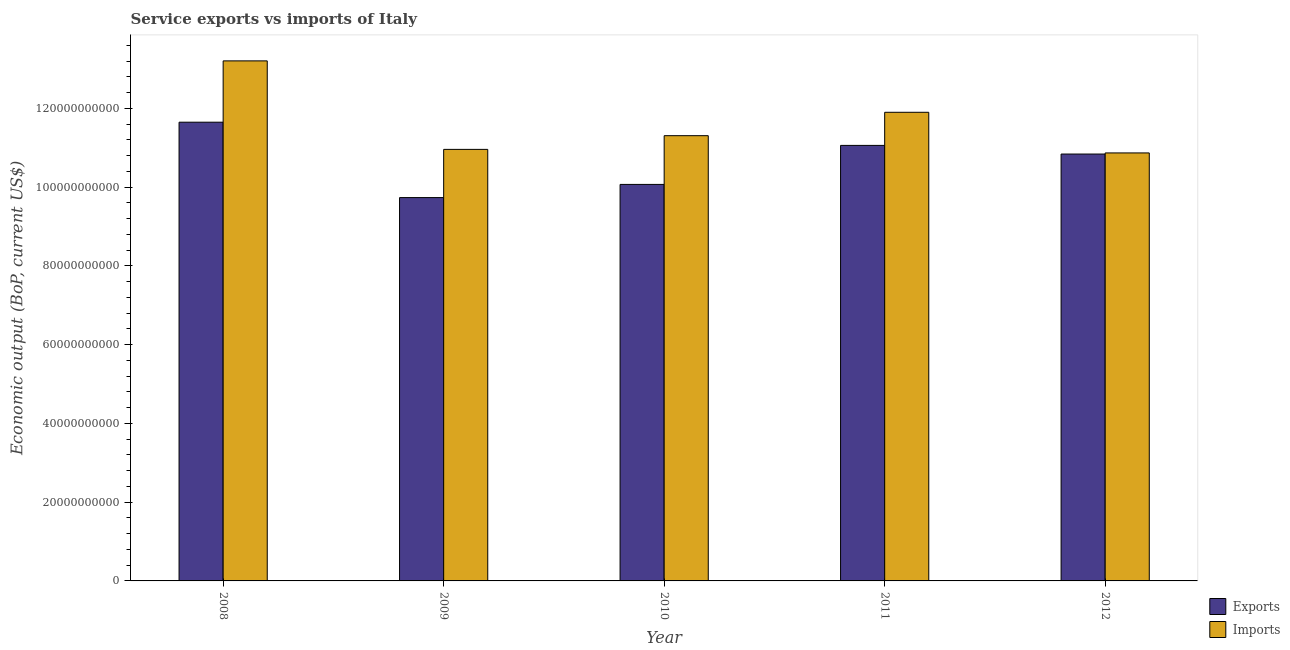Are the number of bars per tick equal to the number of legend labels?
Provide a succinct answer. Yes. How many bars are there on the 4th tick from the left?
Keep it short and to the point. 2. How many bars are there on the 3rd tick from the right?
Your answer should be very brief. 2. What is the label of the 1st group of bars from the left?
Offer a very short reply. 2008. In how many cases, is the number of bars for a given year not equal to the number of legend labels?
Offer a terse response. 0. What is the amount of service exports in 2011?
Make the answer very short. 1.11e+11. Across all years, what is the maximum amount of service exports?
Your answer should be very brief. 1.16e+11. Across all years, what is the minimum amount of service exports?
Your answer should be very brief. 9.73e+1. In which year was the amount of service imports minimum?
Provide a short and direct response. 2012. What is the total amount of service imports in the graph?
Offer a very short reply. 5.82e+11. What is the difference between the amount of service exports in 2009 and that in 2012?
Give a very brief answer. -1.11e+1. What is the difference between the amount of service exports in 2012 and the amount of service imports in 2009?
Provide a short and direct response. 1.11e+1. What is the average amount of service exports per year?
Your response must be concise. 1.07e+11. In the year 2010, what is the difference between the amount of service imports and amount of service exports?
Your answer should be very brief. 0. What is the ratio of the amount of service exports in 2011 to that in 2012?
Provide a succinct answer. 1.02. Is the amount of service imports in 2009 less than that in 2012?
Your answer should be very brief. No. Is the difference between the amount of service exports in 2011 and 2012 greater than the difference between the amount of service imports in 2011 and 2012?
Offer a terse response. No. What is the difference between the highest and the second highest amount of service exports?
Ensure brevity in your answer.  5.89e+09. What is the difference between the highest and the lowest amount of service imports?
Provide a short and direct response. 2.34e+1. In how many years, is the amount of service imports greater than the average amount of service imports taken over all years?
Provide a succinct answer. 2. Is the sum of the amount of service exports in 2010 and 2012 greater than the maximum amount of service imports across all years?
Offer a very short reply. Yes. What does the 2nd bar from the left in 2012 represents?
Keep it short and to the point. Imports. What does the 2nd bar from the right in 2009 represents?
Provide a succinct answer. Exports. Does the graph contain any zero values?
Offer a very short reply. No. Where does the legend appear in the graph?
Offer a terse response. Bottom right. How many legend labels are there?
Provide a succinct answer. 2. What is the title of the graph?
Your answer should be compact. Service exports vs imports of Italy. What is the label or title of the X-axis?
Offer a terse response. Year. What is the label or title of the Y-axis?
Keep it short and to the point. Economic output (BoP, current US$). What is the Economic output (BoP, current US$) of Exports in 2008?
Give a very brief answer. 1.16e+11. What is the Economic output (BoP, current US$) in Imports in 2008?
Your answer should be compact. 1.32e+11. What is the Economic output (BoP, current US$) in Exports in 2009?
Your answer should be very brief. 9.73e+1. What is the Economic output (BoP, current US$) of Imports in 2009?
Your response must be concise. 1.10e+11. What is the Economic output (BoP, current US$) in Exports in 2010?
Your response must be concise. 1.01e+11. What is the Economic output (BoP, current US$) of Imports in 2010?
Provide a short and direct response. 1.13e+11. What is the Economic output (BoP, current US$) in Exports in 2011?
Make the answer very short. 1.11e+11. What is the Economic output (BoP, current US$) in Imports in 2011?
Your answer should be very brief. 1.19e+11. What is the Economic output (BoP, current US$) in Exports in 2012?
Make the answer very short. 1.08e+11. What is the Economic output (BoP, current US$) in Imports in 2012?
Keep it short and to the point. 1.09e+11. Across all years, what is the maximum Economic output (BoP, current US$) in Exports?
Give a very brief answer. 1.16e+11. Across all years, what is the maximum Economic output (BoP, current US$) of Imports?
Offer a terse response. 1.32e+11. Across all years, what is the minimum Economic output (BoP, current US$) in Exports?
Keep it short and to the point. 9.73e+1. Across all years, what is the minimum Economic output (BoP, current US$) of Imports?
Offer a very short reply. 1.09e+11. What is the total Economic output (BoP, current US$) in Exports in the graph?
Ensure brevity in your answer.  5.33e+11. What is the total Economic output (BoP, current US$) in Imports in the graph?
Ensure brevity in your answer.  5.82e+11. What is the difference between the Economic output (BoP, current US$) in Exports in 2008 and that in 2009?
Ensure brevity in your answer.  1.91e+1. What is the difference between the Economic output (BoP, current US$) of Imports in 2008 and that in 2009?
Give a very brief answer. 2.25e+1. What is the difference between the Economic output (BoP, current US$) in Exports in 2008 and that in 2010?
Make the answer very short. 1.58e+1. What is the difference between the Economic output (BoP, current US$) of Imports in 2008 and that in 2010?
Offer a very short reply. 1.90e+1. What is the difference between the Economic output (BoP, current US$) in Exports in 2008 and that in 2011?
Offer a terse response. 5.89e+09. What is the difference between the Economic output (BoP, current US$) of Imports in 2008 and that in 2011?
Provide a short and direct response. 1.31e+1. What is the difference between the Economic output (BoP, current US$) in Exports in 2008 and that in 2012?
Make the answer very short. 8.09e+09. What is the difference between the Economic output (BoP, current US$) in Imports in 2008 and that in 2012?
Keep it short and to the point. 2.34e+1. What is the difference between the Economic output (BoP, current US$) of Exports in 2009 and that in 2010?
Provide a short and direct response. -3.34e+09. What is the difference between the Economic output (BoP, current US$) in Imports in 2009 and that in 2010?
Make the answer very short. -3.48e+09. What is the difference between the Economic output (BoP, current US$) in Exports in 2009 and that in 2011?
Provide a succinct answer. -1.33e+1. What is the difference between the Economic output (BoP, current US$) of Imports in 2009 and that in 2011?
Provide a short and direct response. -9.42e+09. What is the difference between the Economic output (BoP, current US$) in Exports in 2009 and that in 2012?
Make the answer very short. -1.11e+1. What is the difference between the Economic output (BoP, current US$) of Imports in 2009 and that in 2012?
Offer a very short reply. 9.00e+08. What is the difference between the Economic output (BoP, current US$) of Exports in 2010 and that in 2011?
Give a very brief answer. -9.91e+09. What is the difference between the Economic output (BoP, current US$) of Imports in 2010 and that in 2011?
Provide a short and direct response. -5.94e+09. What is the difference between the Economic output (BoP, current US$) of Exports in 2010 and that in 2012?
Provide a short and direct response. -7.71e+09. What is the difference between the Economic output (BoP, current US$) in Imports in 2010 and that in 2012?
Give a very brief answer. 4.38e+09. What is the difference between the Economic output (BoP, current US$) of Exports in 2011 and that in 2012?
Offer a terse response. 2.20e+09. What is the difference between the Economic output (BoP, current US$) in Imports in 2011 and that in 2012?
Provide a short and direct response. 1.03e+1. What is the difference between the Economic output (BoP, current US$) of Exports in 2008 and the Economic output (BoP, current US$) of Imports in 2009?
Provide a short and direct response. 6.90e+09. What is the difference between the Economic output (BoP, current US$) of Exports in 2008 and the Economic output (BoP, current US$) of Imports in 2010?
Offer a terse response. 3.42e+09. What is the difference between the Economic output (BoP, current US$) in Exports in 2008 and the Economic output (BoP, current US$) in Imports in 2011?
Offer a terse response. -2.52e+09. What is the difference between the Economic output (BoP, current US$) of Exports in 2008 and the Economic output (BoP, current US$) of Imports in 2012?
Make the answer very short. 7.80e+09. What is the difference between the Economic output (BoP, current US$) in Exports in 2009 and the Economic output (BoP, current US$) in Imports in 2010?
Your response must be concise. -1.57e+1. What is the difference between the Economic output (BoP, current US$) in Exports in 2009 and the Economic output (BoP, current US$) in Imports in 2011?
Give a very brief answer. -2.17e+1. What is the difference between the Economic output (BoP, current US$) of Exports in 2009 and the Economic output (BoP, current US$) of Imports in 2012?
Provide a short and direct response. -1.13e+1. What is the difference between the Economic output (BoP, current US$) in Exports in 2010 and the Economic output (BoP, current US$) in Imports in 2011?
Ensure brevity in your answer.  -1.83e+1. What is the difference between the Economic output (BoP, current US$) of Exports in 2010 and the Economic output (BoP, current US$) of Imports in 2012?
Give a very brief answer. -8.00e+09. What is the difference between the Economic output (BoP, current US$) of Exports in 2011 and the Economic output (BoP, current US$) of Imports in 2012?
Your response must be concise. 1.91e+09. What is the average Economic output (BoP, current US$) of Exports per year?
Provide a succinct answer. 1.07e+11. What is the average Economic output (BoP, current US$) in Imports per year?
Ensure brevity in your answer.  1.16e+11. In the year 2008, what is the difference between the Economic output (BoP, current US$) in Exports and Economic output (BoP, current US$) in Imports?
Ensure brevity in your answer.  -1.56e+1. In the year 2009, what is the difference between the Economic output (BoP, current US$) of Exports and Economic output (BoP, current US$) of Imports?
Keep it short and to the point. -1.22e+1. In the year 2010, what is the difference between the Economic output (BoP, current US$) in Exports and Economic output (BoP, current US$) in Imports?
Provide a succinct answer. -1.24e+1. In the year 2011, what is the difference between the Economic output (BoP, current US$) of Exports and Economic output (BoP, current US$) of Imports?
Provide a succinct answer. -8.41e+09. In the year 2012, what is the difference between the Economic output (BoP, current US$) in Exports and Economic output (BoP, current US$) in Imports?
Your answer should be very brief. -2.83e+08. What is the ratio of the Economic output (BoP, current US$) of Exports in 2008 to that in 2009?
Provide a succinct answer. 1.2. What is the ratio of the Economic output (BoP, current US$) of Imports in 2008 to that in 2009?
Provide a succinct answer. 1.21. What is the ratio of the Economic output (BoP, current US$) in Exports in 2008 to that in 2010?
Keep it short and to the point. 1.16. What is the ratio of the Economic output (BoP, current US$) of Imports in 2008 to that in 2010?
Ensure brevity in your answer.  1.17. What is the ratio of the Economic output (BoP, current US$) in Exports in 2008 to that in 2011?
Ensure brevity in your answer.  1.05. What is the ratio of the Economic output (BoP, current US$) of Imports in 2008 to that in 2011?
Offer a terse response. 1.11. What is the ratio of the Economic output (BoP, current US$) of Exports in 2008 to that in 2012?
Provide a succinct answer. 1.07. What is the ratio of the Economic output (BoP, current US$) in Imports in 2008 to that in 2012?
Ensure brevity in your answer.  1.22. What is the ratio of the Economic output (BoP, current US$) in Exports in 2009 to that in 2010?
Give a very brief answer. 0.97. What is the ratio of the Economic output (BoP, current US$) of Imports in 2009 to that in 2010?
Provide a short and direct response. 0.97. What is the ratio of the Economic output (BoP, current US$) in Exports in 2009 to that in 2011?
Keep it short and to the point. 0.88. What is the ratio of the Economic output (BoP, current US$) of Imports in 2009 to that in 2011?
Your answer should be compact. 0.92. What is the ratio of the Economic output (BoP, current US$) in Exports in 2009 to that in 2012?
Keep it short and to the point. 0.9. What is the ratio of the Economic output (BoP, current US$) of Imports in 2009 to that in 2012?
Your answer should be compact. 1.01. What is the ratio of the Economic output (BoP, current US$) in Exports in 2010 to that in 2011?
Offer a very short reply. 0.91. What is the ratio of the Economic output (BoP, current US$) in Imports in 2010 to that in 2011?
Provide a short and direct response. 0.95. What is the ratio of the Economic output (BoP, current US$) in Exports in 2010 to that in 2012?
Your answer should be compact. 0.93. What is the ratio of the Economic output (BoP, current US$) in Imports in 2010 to that in 2012?
Offer a terse response. 1.04. What is the ratio of the Economic output (BoP, current US$) in Exports in 2011 to that in 2012?
Your answer should be very brief. 1.02. What is the ratio of the Economic output (BoP, current US$) in Imports in 2011 to that in 2012?
Keep it short and to the point. 1.09. What is the difference between the highest and the second highest Economic output (BoP, current US$) of Exports?
Provide a succinct answer. 5.89e+09. What is the difference between the highest and the second highest Economic output (BoP, current US$) of Imports?
Offer a terse response. 1.31e+1. What is the difference between the highest and the lowest Economic output (BoP, current US$) of Exports?
Ensure brevity in your answer.  1.91e+1. What is the difference between the highest and the lowest Economic output (BoP, current US$) in Imports?
Give a very brief answer. 2.34e+1. 